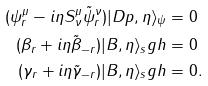Convert formula to latex. <formula><loc_0><loc_0><loc_500><loc_500>( \psi _ { r } ^ { \mu } - i \eta S ^ { \mu } _ { \nu } \tilde { \psi } _ { r } ^ { \nu } ) | D p , \eta \rangle _ { \psi } & = 0 \\ ( \beta _ { r } + i \eta \tilde { \beta } _ { - r } ) | B , \eta \rangle _ { s } g h & = 0 \\ ( \gamma _ { r } + i \eta \tilde { \gamma } _ { - r } ) | B , \eta \rangle _ { s } g h & = 0 .</formula> 